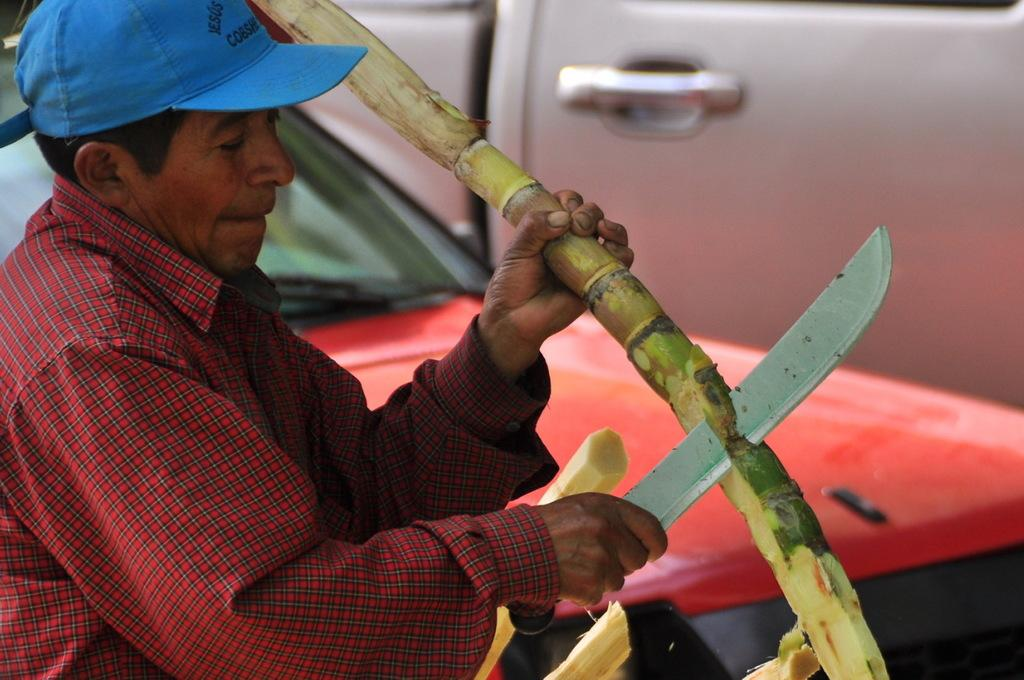Who is present in the image? There is a man in the image. What is the man wearing on his upper body? The man is wearing a red shirt. What is the man wearing on his head? The man is wearing a blue cap. What activity is the man engaged in? The man is cutting a sugarcane stick. What else can be seen in the image besides the man? There are two cars in the image. What type of club does the man use to cut the sugarcane stick in the image? There is no club visible in the image; the man is using a tool that resembles a machete to cut the sugarcane stick. 